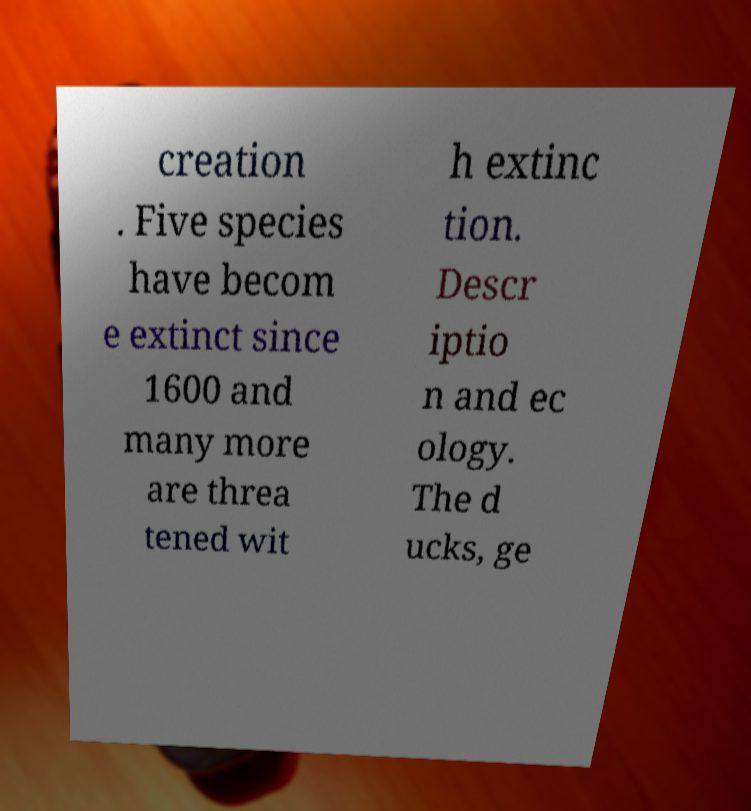Could you extract and type out the text from this image? creation . Five species have becom e extinct since 1600 and many more are threa tened wit h extinc tion. Descr iptio n and ec ology. The d ucks, ge 